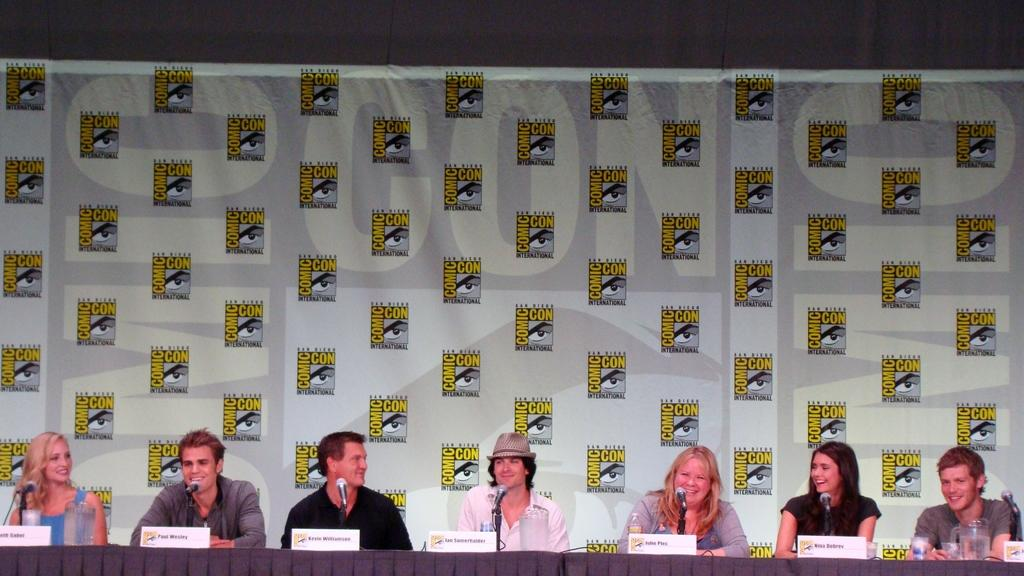What are the people in the image doing? The people in the image are sitting. What objects can be seen in the image that are used for amplifying sound? There are microphones (mics) in the image. What type of surface can be seen in the image that might be used for writing or displaying information? There are boards in the image. What is present on the table in the image? There are objects on a table in the image. What can be seen hanging in the image that contains information or a message? There is a banner in the image. What is written on the banner in the image? There is text written on the banner. How does the manager in the image instruct the team to wash the dishes? There is no manager present in the image, nor is there any mention of washing dishes. 